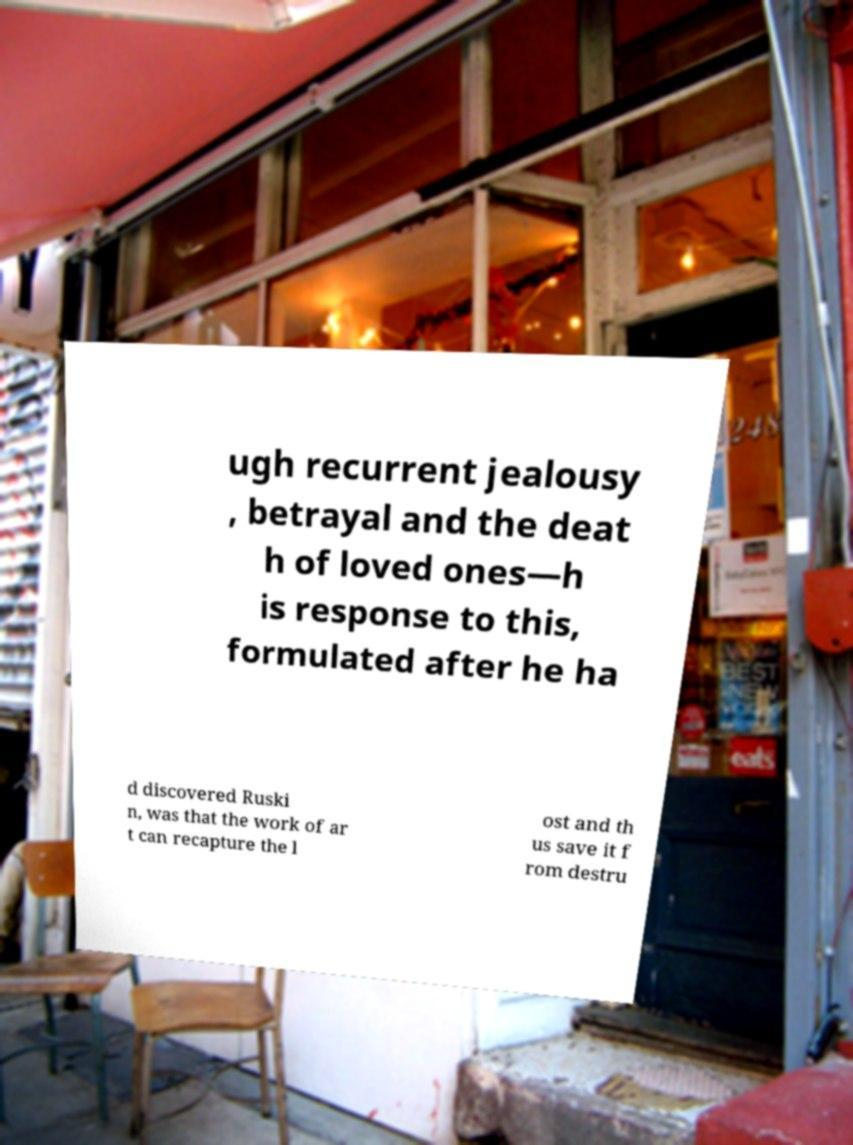Please identify and transcribe the text found in this image. ugh recurrent jealousy , betrayal and the deat h of loved ones—h is response to this, formulated after he ha d discovered Ruski n, was that the work of ar t can recapture the l ost and th us save it f rom destru 